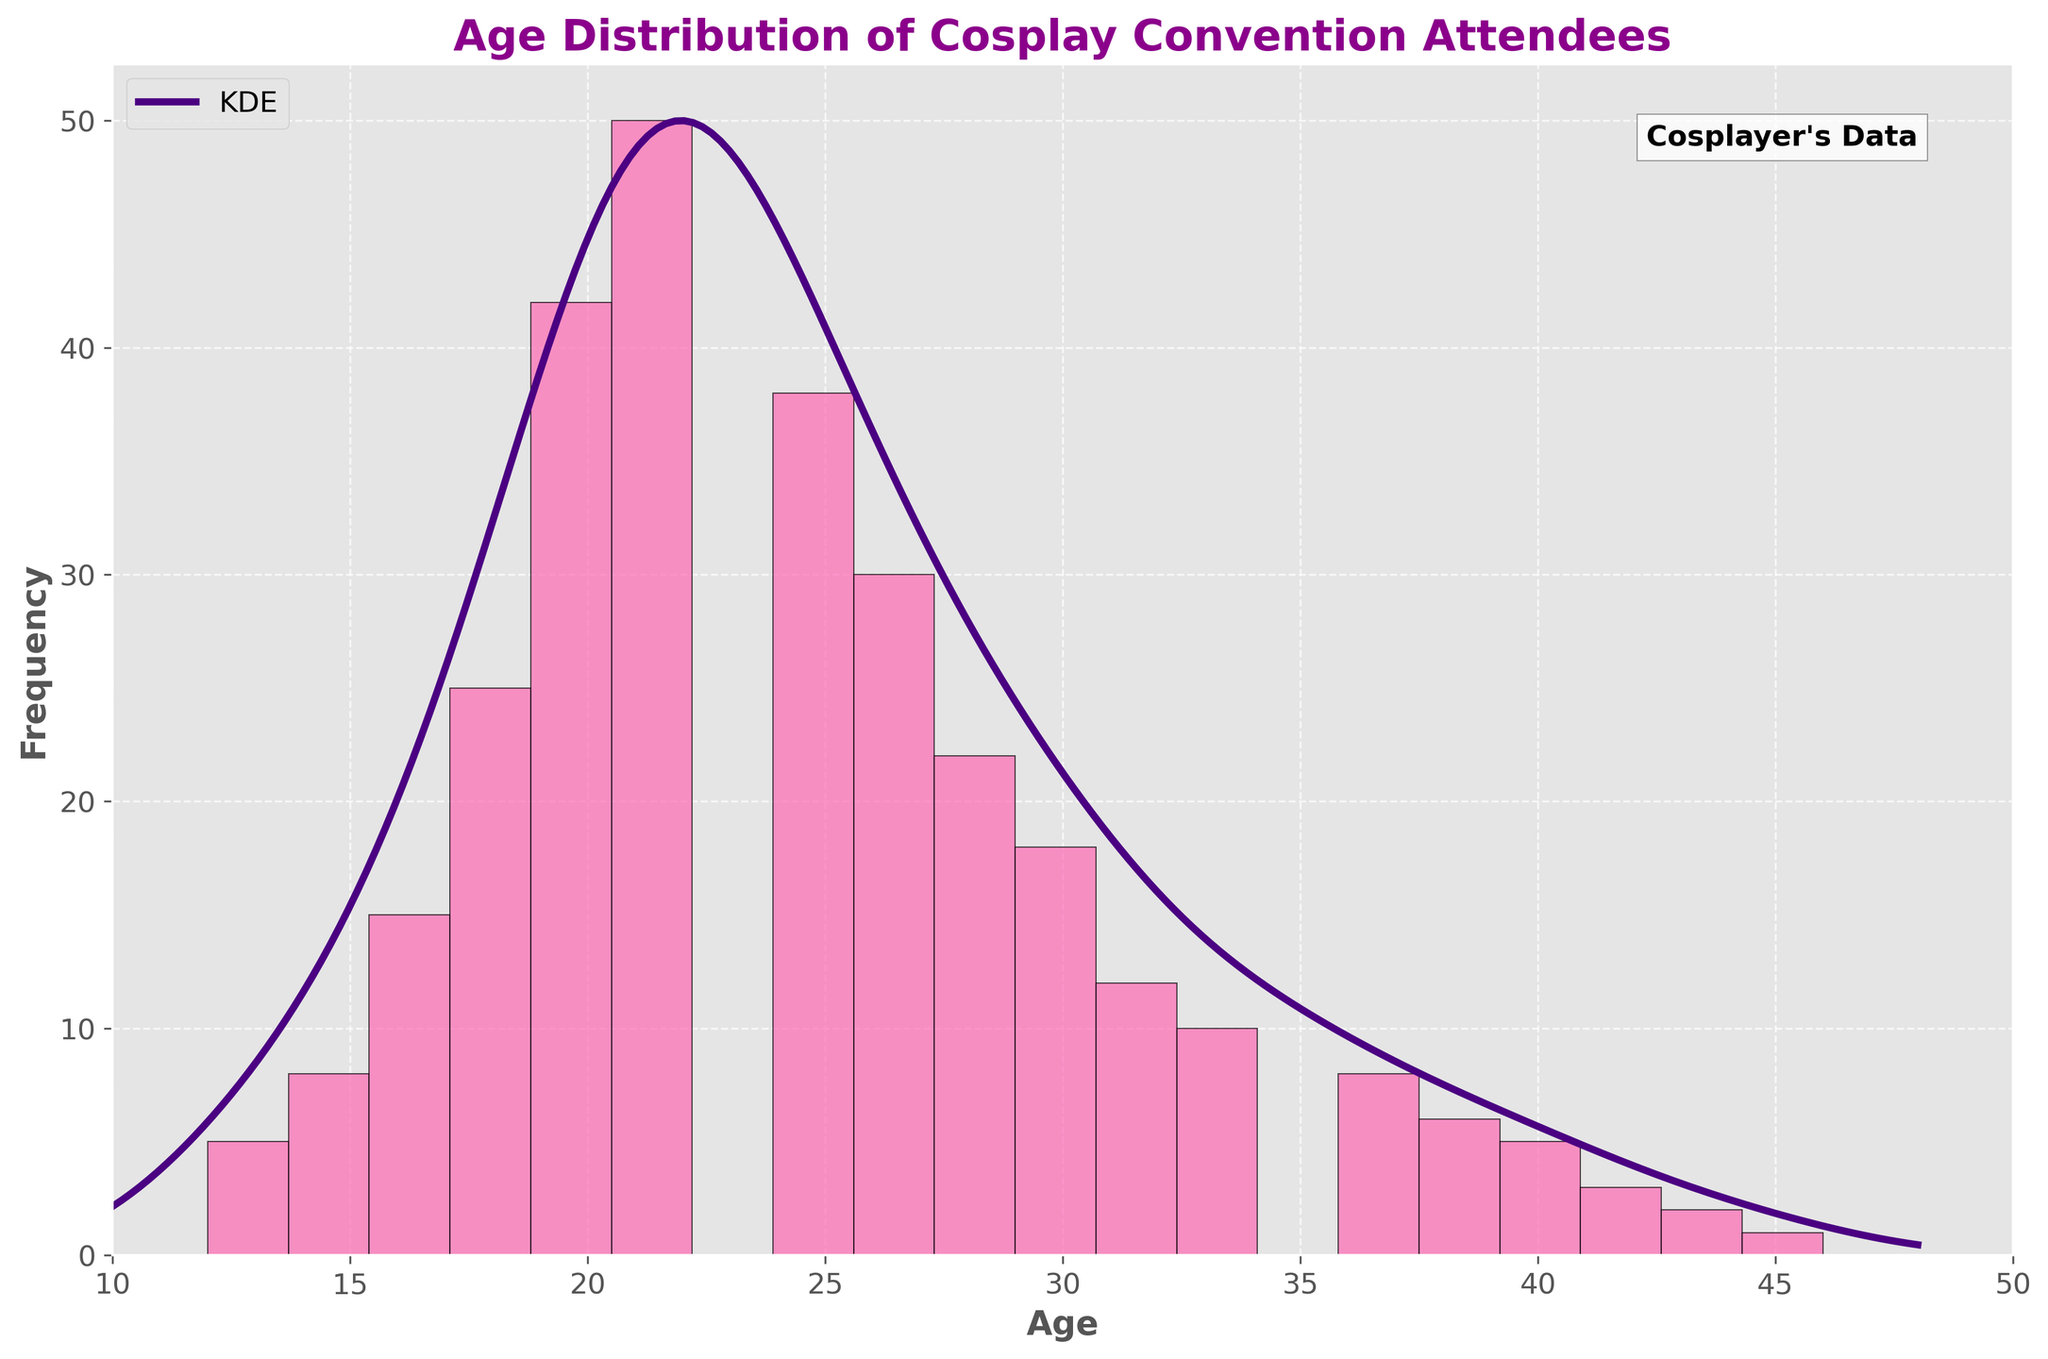What is the title of the figure? The title of the figure is displayed at the top of the graph.
Answer: Age Distribution of Cosplay Convention Attendees Which age group has the highest frequency of attendees? By looking at the histogram, the age group with the highest bar represents the peak frequency.
Answer: 22 What are the x-axis and y-axis labels? The x-axis and y-axis labels are provided along the respective axes at the plot's edges.
Answer: Age and Frequency Based on the KDE curve, around what age do we see a sharp decline in attendance? The KDE curve shows a continuous density estimate; identifying a sharp decline involves observing where the curve starts to drop significantly.
Answer: Around age 30 At what age does the frequency start to decline after the peak? After the peak in the histogram, the frequency begins to drop as age increases.
Answer: After 22 How does the frequency of attendees aged 32 compare to those aged 18? Compare the height of the bars in the histogram for ages 32 and 18.
Answer: Lower for 32 than for 18 Which age groups have the smallest frequency of attendees? Look for the smallest bars in the histogram.
Answer: 46 and above What's the most likely age range for attendees based on the KDE curve? The KDE curve peak represents the most common ages; find the range around this peak.
Answer: 20-26 Identify the frequency for the age group 24 by looking at the histogram. The height of the bar corresponding to age 24 shows the frequency.
Answer: 38 Is the overall distribution of age skewed, and if so, in which direction? Analyze the shape of the histogram and KDE curve; skewness is determined by the tail end.
Answer: Slightly skewed to the right 